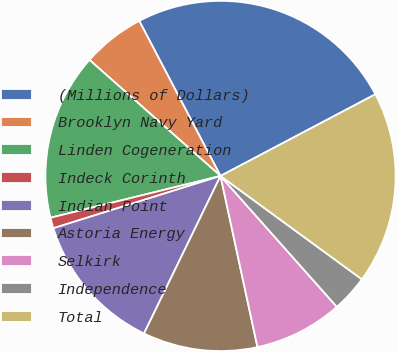Convert chart. <chart><loc_0><loc_0><loc_500><loc_500><pie_chart><fcel>(Millions of Dollars)<fcel>Brooklyn Navy Yard<fcel>Linden Cogeneration<fcel>Indeck Corinth<fcel>Indian Point<fcel>Astoria Energy<fcel>Selkirk<fcel>Independence<fcel>Total<nl><fcel>24.96%<fcel>5.78%<fcel>15.37%<fcel>0.99%<fcel>12.98%<fcel>10.58%<fcel>8.18%<fcel>3.39%<fcel>17.77%<nl></chart> 